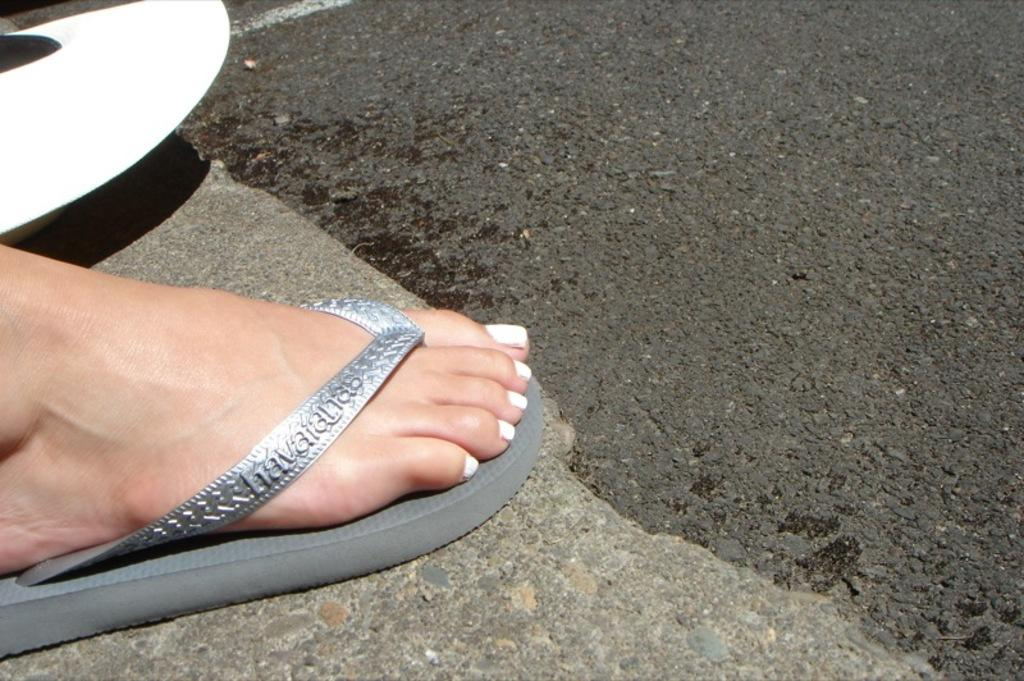What can be seen on the left side of the image? There is a leg on the left side of the image. What type of disgust can be seen on the leg in the image? There is no indication of disgust in the image; it only shows a leg. How many goldfish are swimming around the leg in the image? There are no goldfish present in the image; it only shows a leg. 